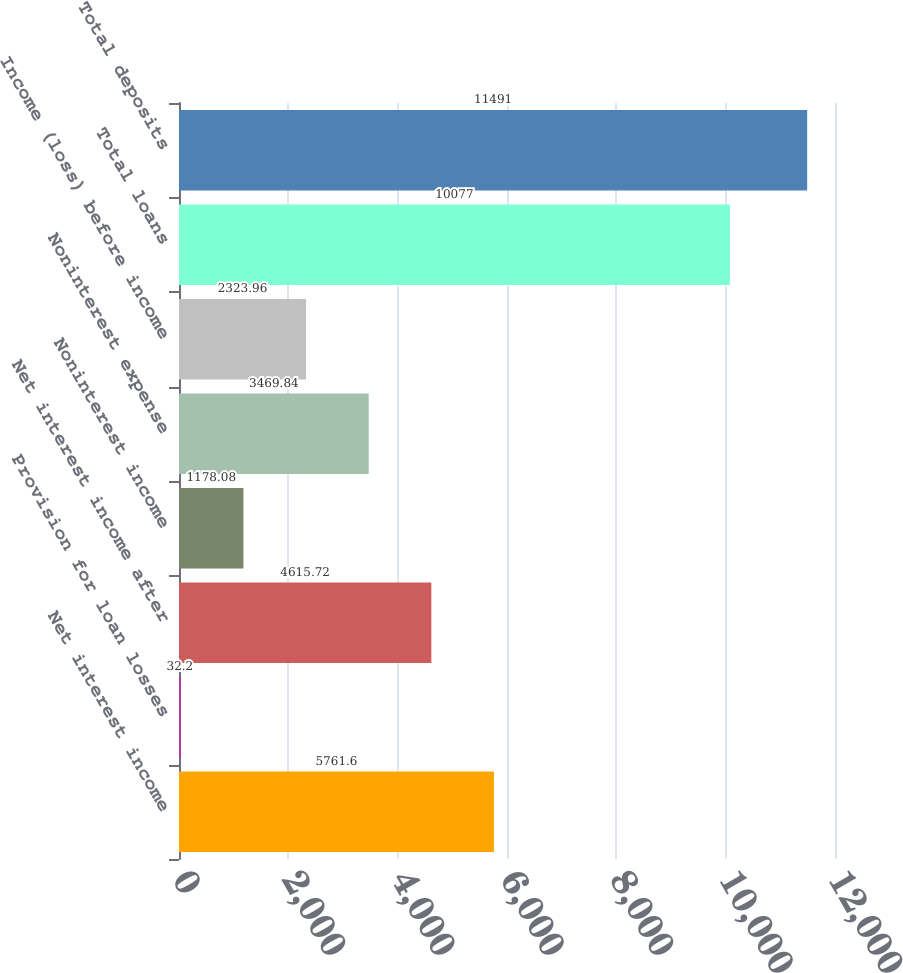Convert chart to OTSL. <chart><loc_0><loc_0><loc_500><loc_500><bar_chart><fcel>Net interest income<fcel>Provision for loan losses<fcel>Net interest income after<fcel>Noninterest income<fcel>Noninterest expense<fcel>Income (loss) before income<fcel>Total loans<fcel>Total deposits<nl><fcel>5761.6<fcel>32.2<fcel>4615.72<fcel>1178.08<fcel>3469.84<fcel>2323.96<fcel>10077<fcel>11491<nl></chart> 